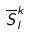<formula> <loc_0><loc_0><loc_500><loc_500>\overline { S } _ { l } ^ { k }</formula> 